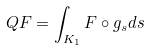Convert formula to latex. <formula><loc_0><loc_0><loc_500><loc_500>Q F = \int _ { K _ { 1 } } F \circ g _ { s } d s</formula> 